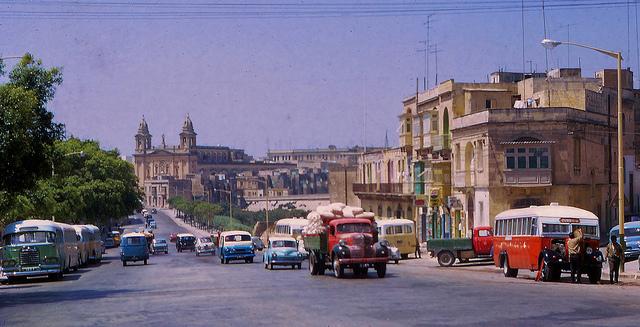Toward which way is the traffic moving?
Write a very short answer. Right. Are there any cars driving in the road?
Quick response, please. Yes. Are there any tall skyscrapers in this picture?
Short answer required. No. Why might we assume this photo was taken before 1999?
Keep it brief. Cars. Are there skyscrapers?
Answer briefly. No. Is the bus moving?
Keep it brief. No. 